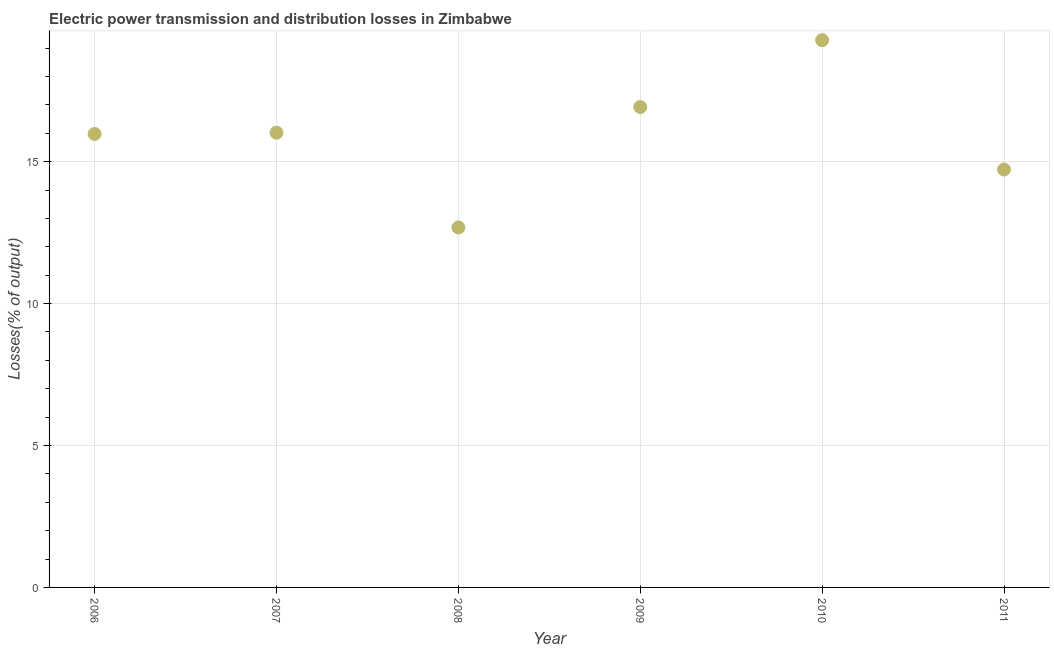What is the electric power transmission and distribution losses in 2008?
Make the answer very short. 12.68. Across all years, what is the maximum electric power transmission and distribution losses?
Ensure brevity in your answer.  19.28. Across all years, what is the minimum electric power transmission and distribution losses?
Provide a succinct answer. 12.68. What is the sum of the electric power transmission and distribution losses?
Your answer should be compact. 95.61. What is the difference between the electric power transmission and distribution losses in 2007 and 2010?
Make the answer very short. -3.26. What is the average electric power transmission and distribution losses per year?
Offer a very short reply. 15.93. What is the median electric power transmission and distribution losses?
Give a very brief answer. 16. In how many years, is the electric power transmission and distribution losses greater than 15 %?
Your answer should be very brief. 4. What is the ratio of the electric power transmission and distribution losses in 2006 to that in 2008?
Give a very brief answer. 1.26. What is the difference between the highest and the second highest electric power transmission and distribution losses?
Make the answer very short. 2.35. What is the difference between the highest and the lowest electric power transmission and distribution losses?
Your answer should be very brief. 6.6. In how many years, is the electric power transmission and distribution losses greater than the average electric power transmission and distribution losses taken over all years?
Give a very brief answer. 4. Does the electric power transmission and distribution losses monotonically increase over the years?
Offer a terse response. No. How many dotlines are there?
Make the answer very short. 1. Are the values on the major ticks of Y-axis written in scientific E-notation?
Offer a terse response. No. What is the title of the graph?
Offer a very short reply. Electric power transmission and distribution losses in Zimbabwe. What is the label or title of the Y-axis?
Your response must be concise. Losses(% of output). What is the Losses(% of output) in 2006?
Offer a terse response. 15.98. What is the Losses(% of output) in 2007?
Make the answer very short. 16.02. What is the Losses(% of output) in 2008?
Provide a succinct answer. 12.68. What is the Losses(% of output) in 2009?
Keep it short and to the point. 16.92. What is the Losses(% of output) in 2010?
Keep it short and to the point. 19.28. What is the Losses(% of output) in 2011?
Provide a short and direct response. 14.72. What is the difference between the Losses(% of output) in 2006 and 2007?
Offer a very short reply. -0.04. What is the difference between the Losses(% of output) in 2006 and 2008?
Give a very brief answer. 3.29. What is the difference between the Losses(% of output) in 2006 and 2009?
Provide a succinct answer. -0.95. What is the difference between the Losses(% of output) in 2006 and 2010?
Offer a terse response. -3.3. What is the difference between the Losses(% of output) in 2006 and 2011?
Provide a succinct answer. 1.25. What is the difference between the Losses(% of output) in 2007 and 2008?
Your answer should be very brief. 3.34. What is the difference between the Losses(% of output) in 2007 and 2009?
Make the answer very short. -0.9. What is the difference between the Losses(% of output) in 2007 and 2010?
Offer a terse response. -3.26. What is the difference between the Losses(% of output) in 2007 and 2011?
Your response must be concise. 1.3. What is the difference between the Losses(% of output) in 2008 and 2009?
Ensure brevity in your answer.  -4.24. What is the difference between the Losses(% of output) in 2008 and 2010?
Your response must be concise. -6.6. What is the difference between the Losses(% of output) in 2008 and 2011?
Keep it short and to the point. -2.04. What is the difference between the Losses(% of output) in 2009 and 2010?
Provide a short and direct response. -2.35. What is the difference between the Losses(% of output) in 2009 and 2011?
Your response must be concise. 2.2. What is the difference between the Losses(% of output) in 2010 and 2011?
Provide a short and direct response. 4.56. What is the ratio of the Losses(% of output) in 2006 to that in 2008?
Your answer should be compact. 1.26. What is the ratio of the Losses(% of output) in 2006 to that in 2009?
Your answer should be compact. 0.94. What is the ratio of the Losses(% of output) in 2006 to that in 2010?
Provide a short and direct response. 0.83. What is the ratio of the Losses(% of output) in 2006 to that in 2011?
Give a very brief answer. 1.08. What is the ratio of the Losses(% of output) in 2007 to that in 2008?
Offer a very short reply. 1.26. What is the ratio of the Losses(% of output) in 2007 to that in 2009?
Offer a very short reply. 0.95. What is the ratio of the Losses(% of output) in 2007 to that in 2010?
Offer a very short reply. 0.83. What is the ratio of the Losses(% of output) in 2007 to that in 2011?
Your response must be concise. 1.09. What is the ratio of the Losses(% of output) in 2008 to that in 2009?
Your response must be concise. 0.75. What is the ratio of the Losses(% of output) in 2008 to that in 2010?
Provide a short and direct response. 0.66. What is the ratio of the Losses(% of output) in 2008 to that in 2011?
Offer a terse response. 0.86. What is the ratio of the Losses(% of output) in 2009 to that in 2010?
Offer a very short reply. 0.88. What is the ratio of the Losses(% of output) in 2009 to that in 2011?
Your answer should be very brief. 1.15. What is the ratio of the Losses(% of output) in 2010 to that in 2011?
Provide a succinct answer. 1.31. 